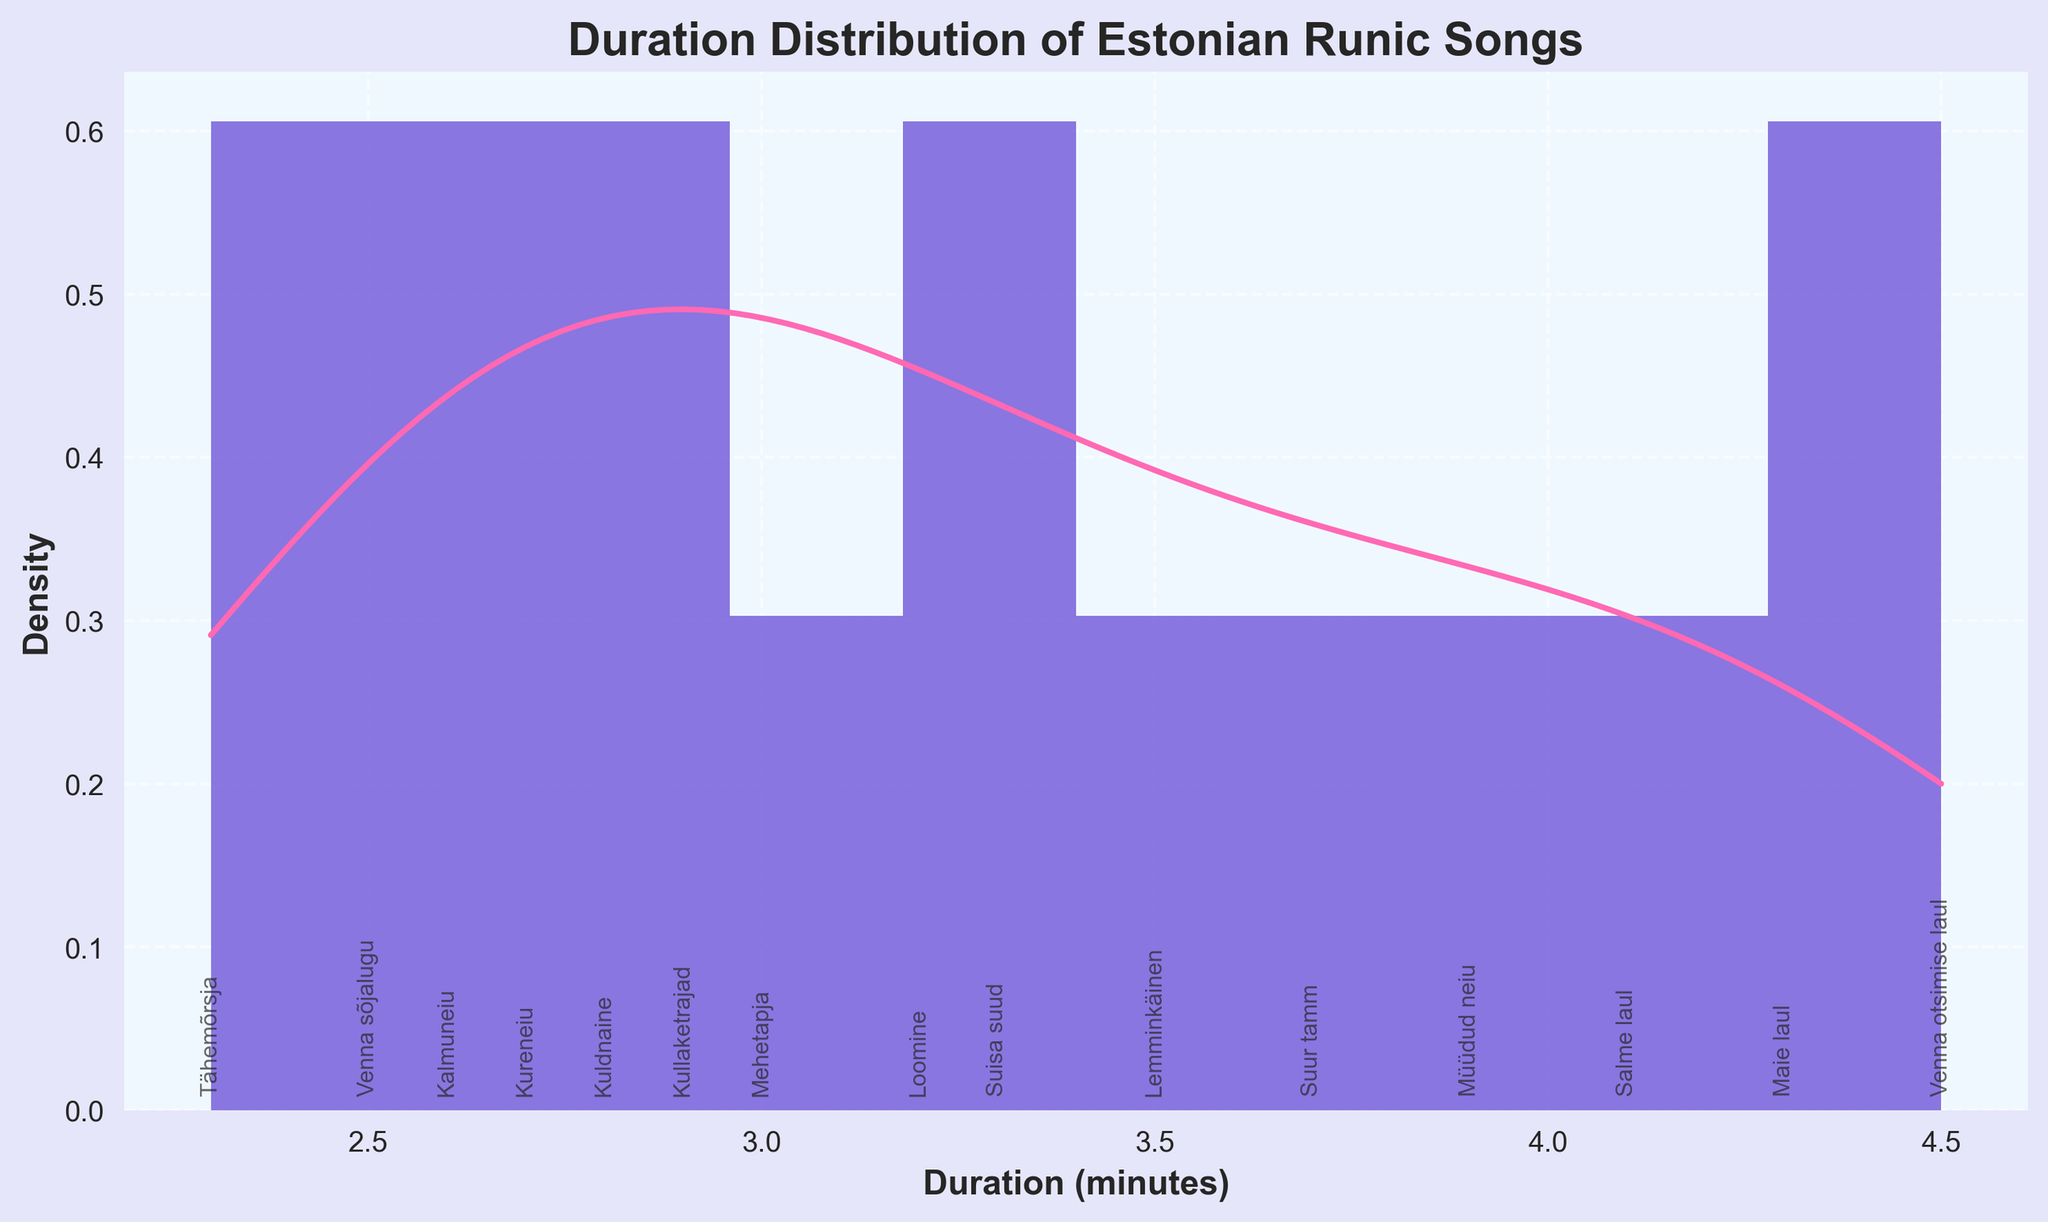What is the title of the plot? The title is typically found at the top of the plot. In this case, it is a bold and larger text that indicates the main subject of the plot.
Answer: Duration Distribution of Estonian Runic Songs What does the x-axis represent? The x-axis represents the different categories or values being measured. In this plot, it shows the duration of the songs in minutes.
Answer: Duration (minutes) What does the y-axis represent? The y-axis usually shows the measured quantity or frequency. In this plot, it represents the density of the song durations.
Answer: Density How many bins are there in the histogram? You can count the number of bins directly from the histogram. Each distinct bar represents one bin.
Answer: 10 Which song has the shortest duration? Look at the annotations along the x-axis to find the song title with the smallest value on the x-axis.
Answer: Tähemõrsja Which song has the longest duration? Similar to finding the shortest duration song, but look for the song title with the highest value on the x-axis.
Answer: Venna otsimise laul What is the approximate duration range of most songs? Based on the histogram and KDE, observe where most of the bars and density are concentrated.
Answer: Approximately 2.5 to 4.0 minutes What is the most common duration range for these songs? Look for the tallest bar in the histogram, as it represents the most frequent duration range.
Answer: 3.0 to 3.5 minutes How does the KDE curve help in understanding the data distribution? The KDE curve smooths the histogram and helps visualize the density of the data points, showing where the data is concentrated and giving a sense of the distribution shape.
Answer: It shows data concentration and distribution shape Is the duration distribution of Estonian runic songs unimodal or multimodal? By looking at the KDE curve, assess whether there is one peak (unimodal) or multiple peaks (multimodal).
Answer: Unimodal 